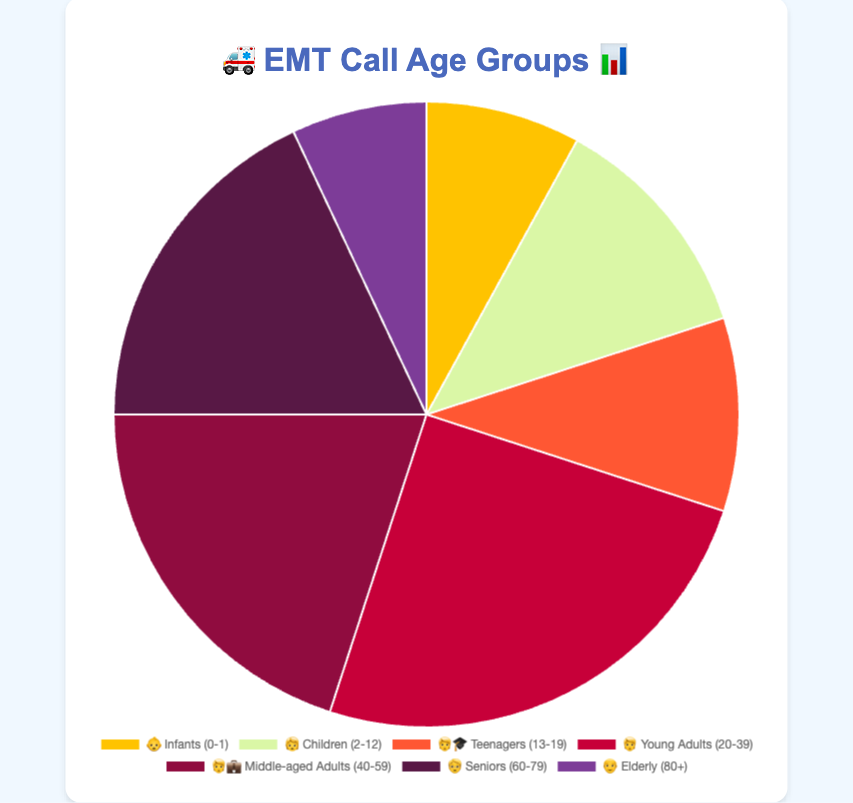Which age group has the highest percentage of EMT calls? By looking at the chart, the segment representing "Young Adults (20-39)" with the emoji 🧑 is the largest. The percentage displayed for this group is 25%.
Answer: Young Adults (20-39) What is the total percentage of EMT calls for patients aged 60 and above? Add up the percentages for "Seniors (60-79)" and "Elderly (80+)" groups. Seniors have 18% and Elderly have 7%, so 18% + 7% = 25%.
Answer: 25% How does the percentage of EMT calls for "Middle-aged Adults (40-59)" compare to "Teenagers (13-19)"? The percentage for "Middle-aged Adults (40-59)" is 20% and for "Teenagers (13-19)" it is 10%. 20% is greater than 10%.
Answer: Middle-aged Adults (40-59) Which age group has the smallest percentage representation in EMT calls? By inspecting the chart, the segment with the emoji 👴 for "Elderly (80+)" is the smallest, with a percentage of 7%.
Answer: Elderly (80+) What is the combined percentage of EMT calls for patients aged between 0-12? Summing the percentages for "Infants (0-1)" and "Children (2-12)" involves adding 8% and 12%. So, 8% + 12% = 20%.
Answer: 20% What emoji represents the age group with the second-highest percentage of EMT calls? The second-largest segment in the chart represents "Middle-aged Adults (40-59)" with a percentage of 20%. The corresponding emoji is 🧑‍💼.
Answer: 🧑‍💼 How many age groups have a percentage greater than 15%? The age groups "Young Adults (20-39)" with 25%, "Middle-aged Adults (40-59)" with 20%, and "Seniors (60-79)" with 18% all have percentages greater than 15%. There are three such groups.
Answer: 3 Which age group has a percentage less than "Infants (0-1)"? The "Infants (0-1)" group has a percentage of 8%. The "Teenagers (13-19)" with 10%, "Children (2-12)" with 12%, and all others except the "Elderly (80+)" with 7% have a higher percentage. So, only "Elderly (80+)" is less than 8%.
Answer: Elderly (80+) What is the difference in percentage between "Teenagers (13-19)" and "Children (2-12)"? The percentage for "Children (2-12)" is 12% and for "Teenagers (13-19)" it is 10%. The difference is 12% - 10% = 2%.
Answer: 2% 